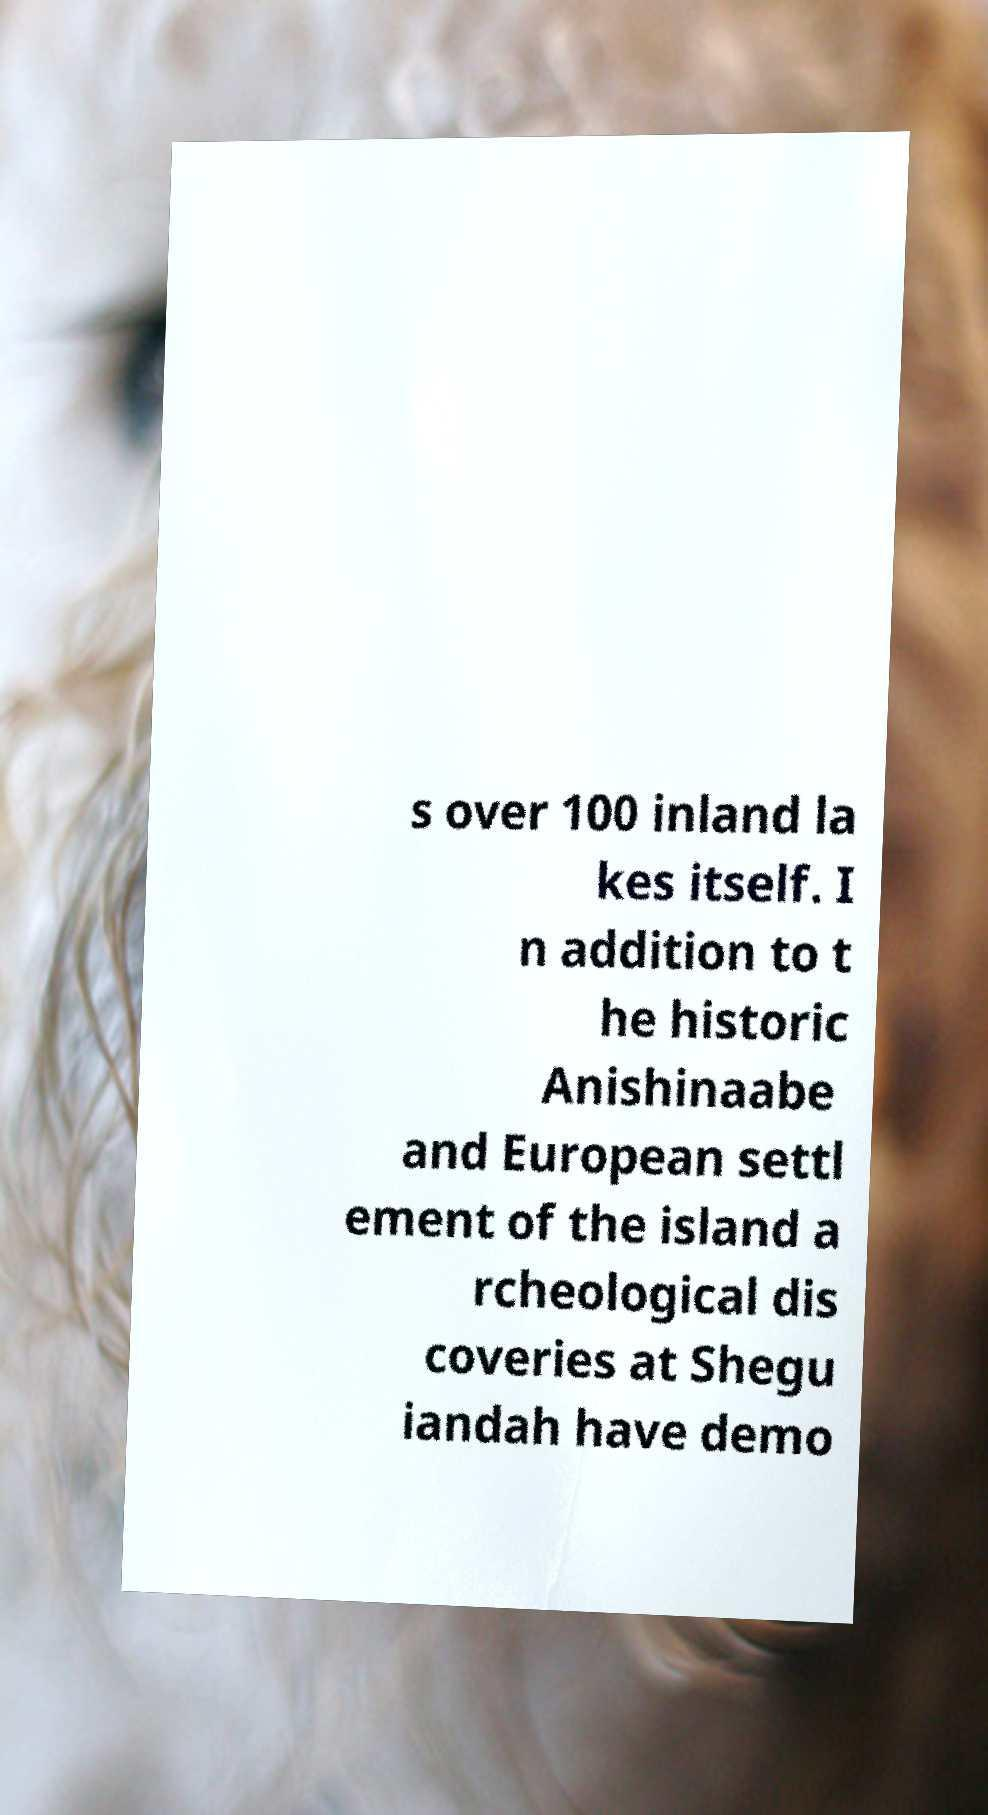Please read and relay the text visible in this image. What does it say? s over 100 inland la kes itself. I n addition to t he historic Anishinaabe and European settl ement of the island a rcheological dis coveries at Shegu iandah have demo 